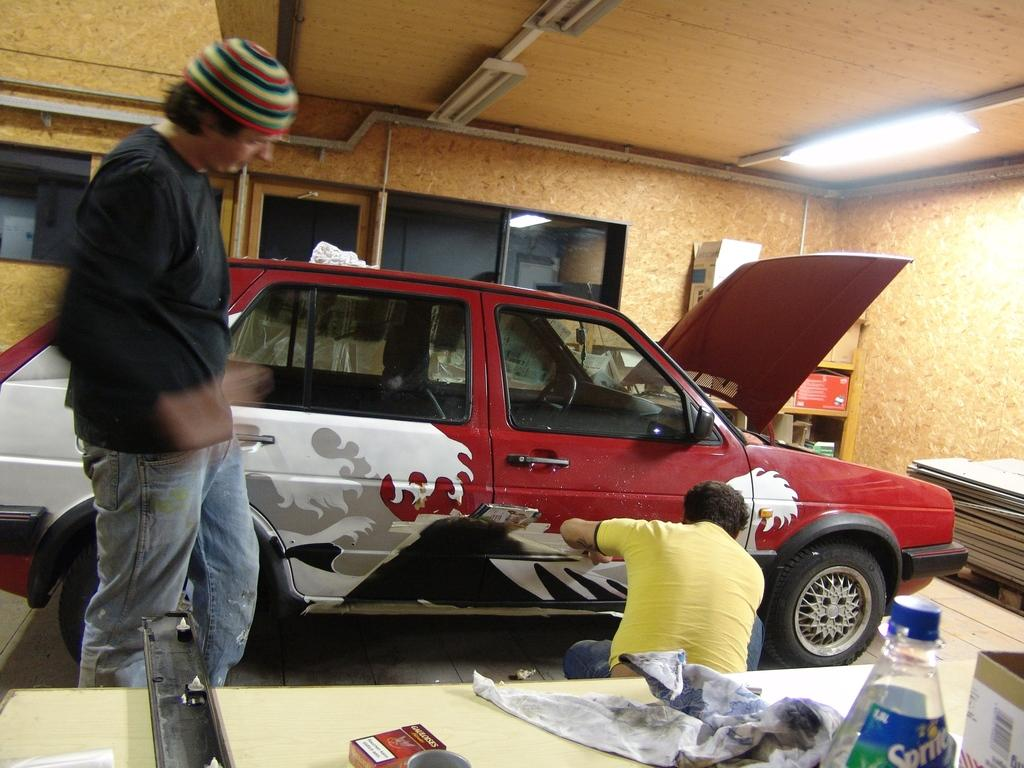What is the man in the image doing to the car? There is a man stickering a car in the image. What is the other man in the image doing? There is another man standing and looking at the car. Can you describe any other objects in the image? Yes, there is a table in the image. How many pets are visible in the image? There are no pets visible in the image. What does the man need to complete the task in the image? The facts provided do not mention any specific tools or materials needed for the task, so it cannot be determined from the image. 